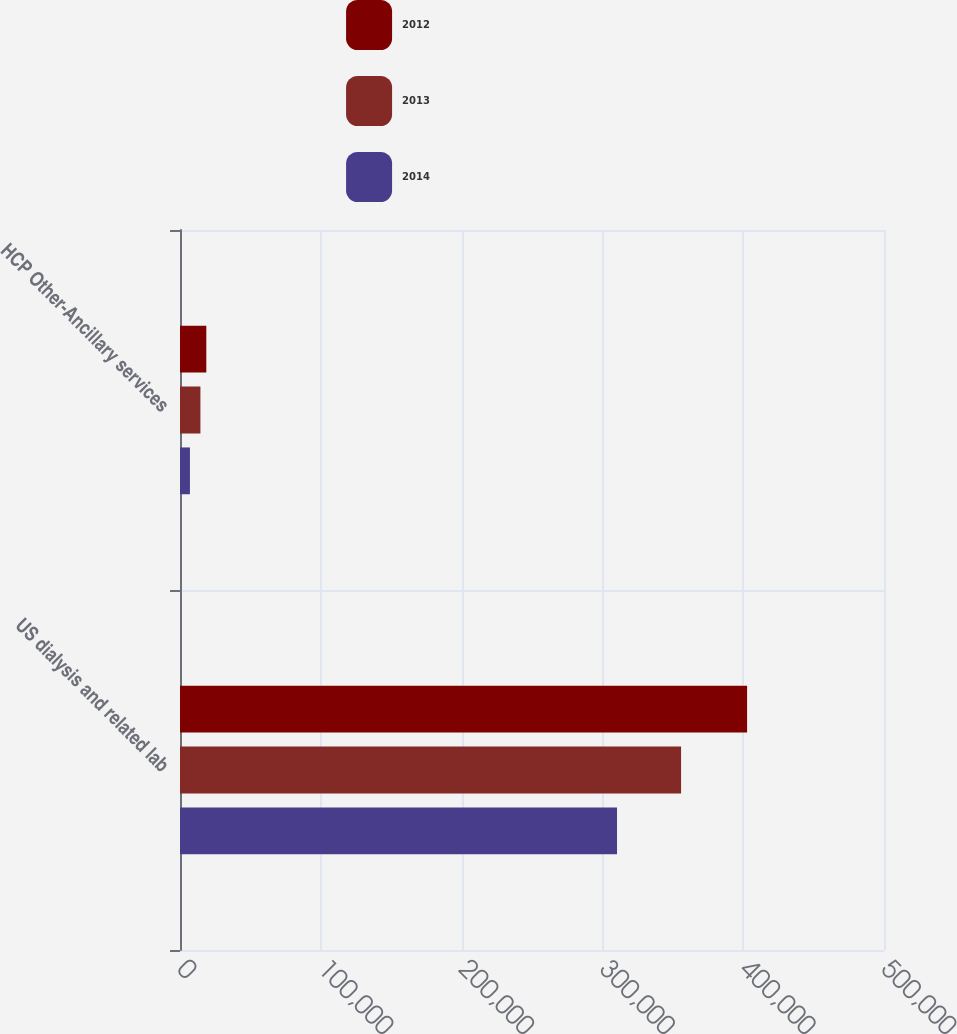<chart> <loc_0><loc_0><loc_500><loc_500><stacked_bar_chart><ecel><fcel>US dialysis and related lab<fcel>HCP Other-Ancillary services<nl><fcel>2012<fcel>402767<fcel>18683<nl><fcel>2013<fcel>355879<fcel>14502<nl><fcel>2014<fcel>310375<fcel>7050<nl></chart> 